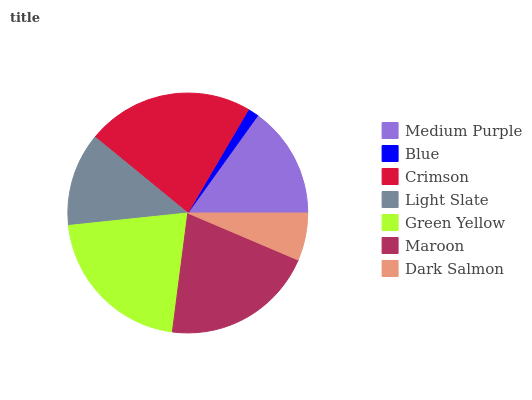Is Blue the minimum?
Answer yes or no. Yes. Is Crimson the maximum?
Answer yes or no. Yes. Is Crimson the minimum?
Answer yes or no. No. Is Blue the maximum?
Answer yes or no. No. Is Crimson greater than Blue?
Answer yes or no. Yes. Is Blue less than Crimson?
Answer yes or no. Yes. Is Blue greater than Crimson?
Answer yes or no. No. Is Crimson less than Blue?
Answer yes or no. No. Is Medium Purple the high median?
Answer yes or no. Yes. Is Medium Purple the low median?
Answer yes or no. Yes. Is Green Yellow the high median?
Answer yes or no. No. Is Dark Salmon the low median?
Answer yes or no. No. 